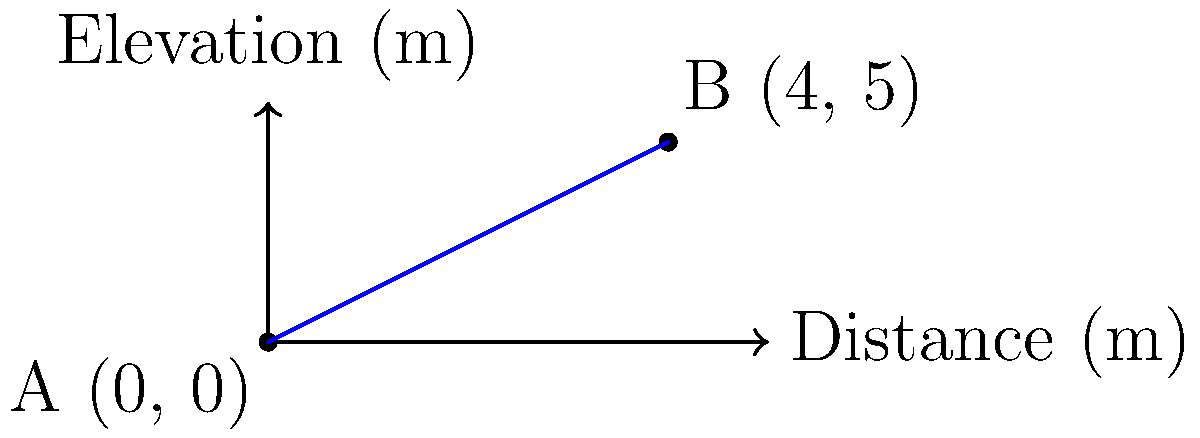As a concrete supplier, you're asked to determine the slope of a concrete ramp for a construction project. The ramp starts at point A (0, 0) and ends at point B (4, 5), where the coordinates represent (distance in meters, elevation in meters). Calculate the slope of the ramp as a percentage. To calculate the slope of the ramp as a percentage, we'll follow these steps:

1. Identify the change in elevation (rise):
   Rise = Elevation at B - Elevation at A
   Rise = 5 m - 0 m = 5 m

2. Identify the change in horizontal distance (run):
   Run = Distance at B - Distance at A
   Run = 4 m - 0 m = 4 m

3. Calculate the slope as a ratio:
   Slope (ratio) = Rise / Run
   Slope (ratio) = 5 m / 4 m = 1.25

4. Convert the slope to a percentage:
   Slope (percentage) = Slope (ratio) × 100%
   Slope (percentage) = 1.25 × 100% = 125%

Therefore, the slope of the concrete ramp is 125%.
Answer: 125% 